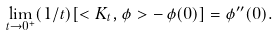<formula> <loc_0><loc_0><loc_500><loc_500>\lim _ { t \to 0 ^ { + } } ( 1 / t ) [ < K _ { t } , \phi > - \, \phi ( 0 ) ] = \phi ^ { \prime \prime } ( 0 ) .</formula> 